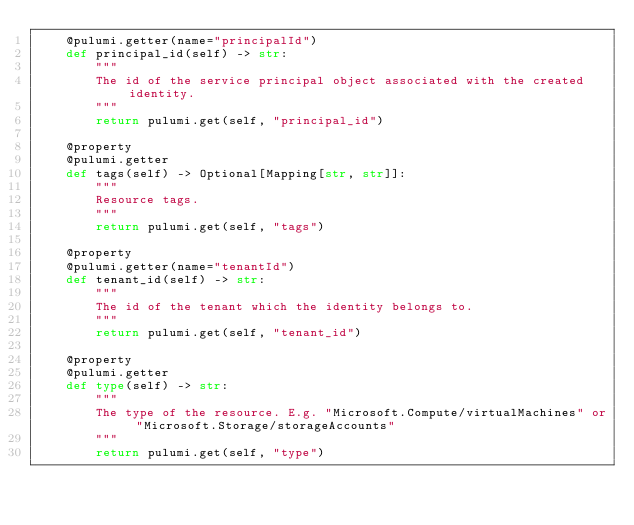Convert code to text. <code><loc_0><loc_0><loc_500><loc_500><_Python_>    @pulumi.getter(name="principalId")
    def principal_id(self) -> str:
        """
        The id of the service principal object associated with the created identity.
        """
        return pulumi.get(self, "principal_id")

    @property
    @pulumi.getter
    def tags(self) -> Optional[Mapping[str, str]]:
        """
        Resource tags.
        """
        return pulumi.get(self, "tags")

    @property
    @pulumi.getter(name="tenantId")
    def tenant_id(self) -> str:
        """
        The id of the tenant which the identity belongs to.
        """
        return pulumi.get(self, "tenant_id")

    @property
    @pulumi.getter
    def type(self) -> str:
        """
        The type of the resource. E.g. "Microsoft.Compute/virtualMachines" or "Microsoft.Storage/storageAccounts"
        """
        return pulumi.get(self, "type")

</code> 